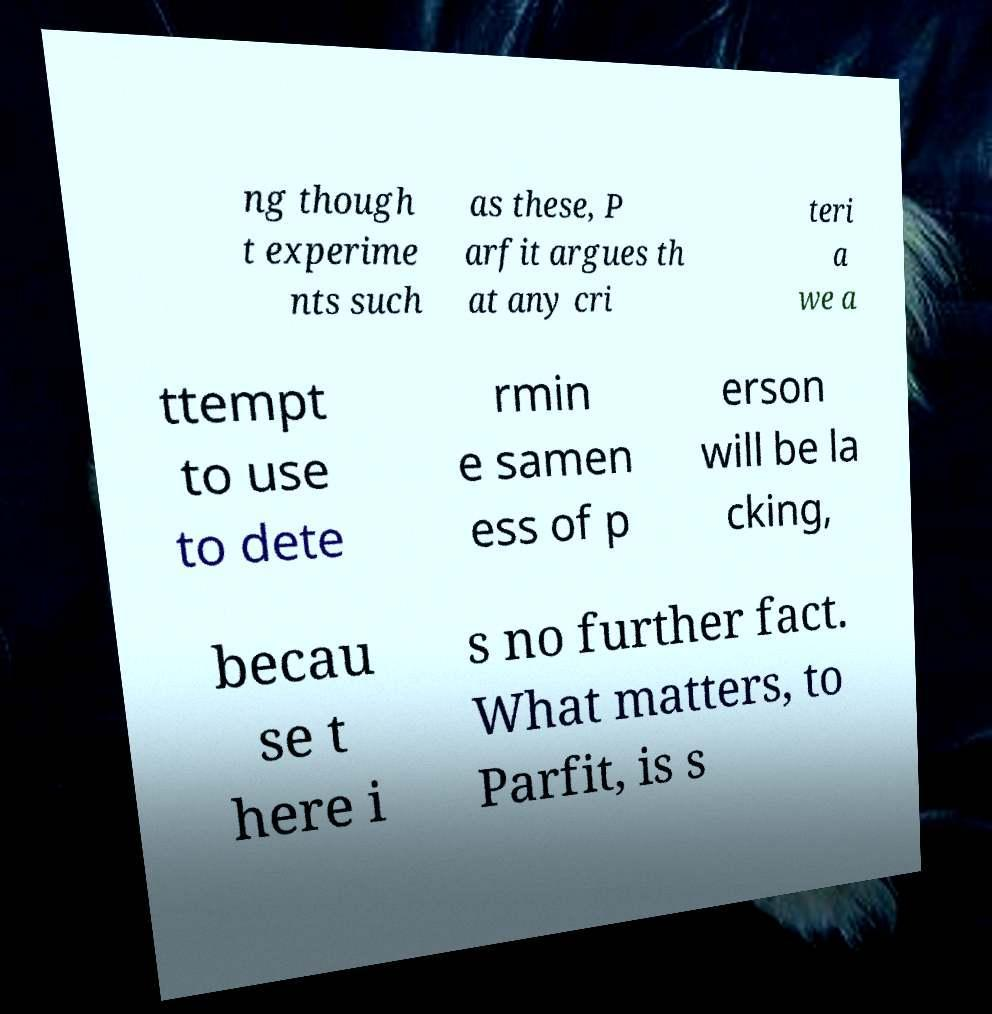Please read and relay the text visible in this image. What does it say? ng though t experime nts such as these, P arfit argues th at any cri teri a we a ttempt to use to dete rmin e samen ess of p erson will be la cking, becau se t here i s no further fact. What matters, to Parfit, is s 